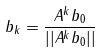Convert formula to latex. <formula><loc_0><loc_0><loc_500><loc_500>b _ { k } = \frac { A ^ { k } b _ { 0 } } { | | A ^ { k } b _ { 0 } | | }</formula> 